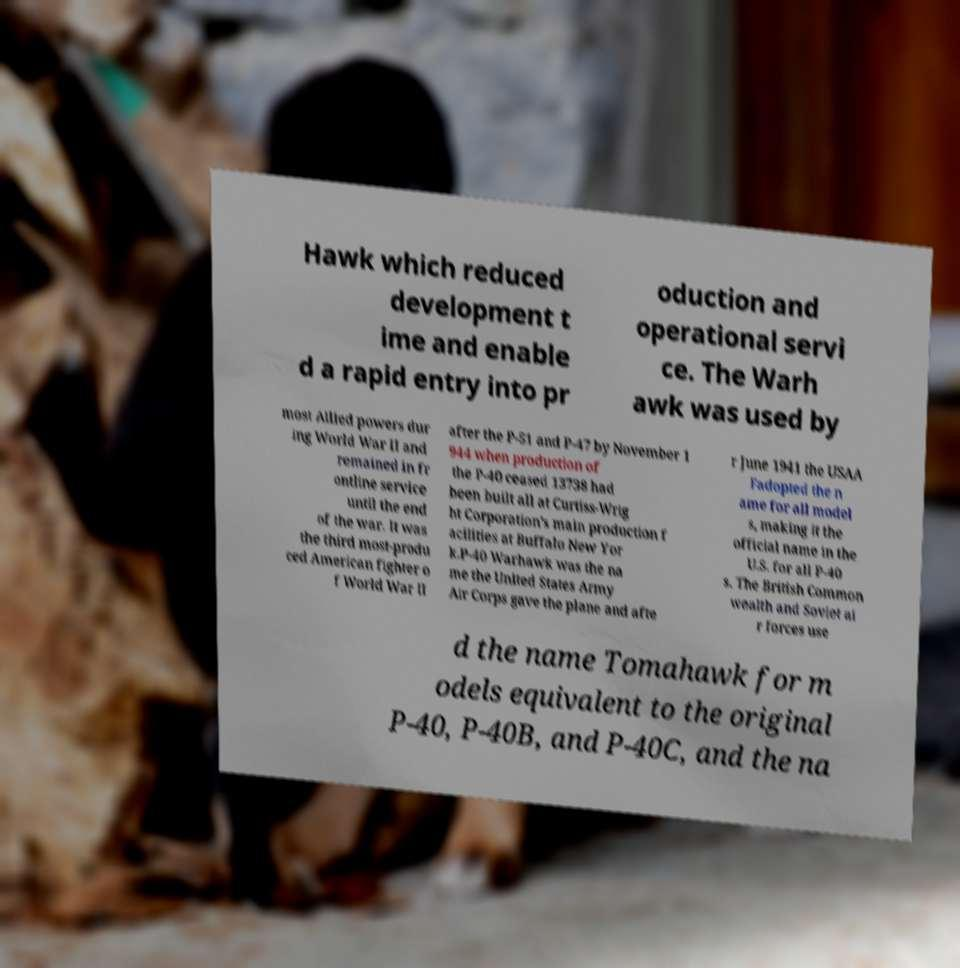Can you read and provide the text displayed in the image?This photo seems to have some interesting text. Can you extract and type it out for me? Hawk which reduced development t ime and enable d a rapid entry into pr oduction and operational servi ce. The Warh awk was used by most Allied powers dur ing World War II and remained in fr ontline service until the end of the war. It was the third most-produ ced American fighter o f World War II after the P-51 and P-47 by November 1 944 when production of the P-40 ceased 13738 had been built all at Curtiss-Wrig ht Corporation's main production f acilities at Buffalo New Yor k.P-40 Warhawk was the na me the United States Army Air Corps gave the plane and afte r June 1941 the USAA Fadopted the n ame for all model s, making it the official name in the U.S. for all P-40 s. The British Common wealth and Soviet ai r forces use d the name Tomahawk for m odels equivalent to the original P-40, P-40B, and P-40C, and the na 